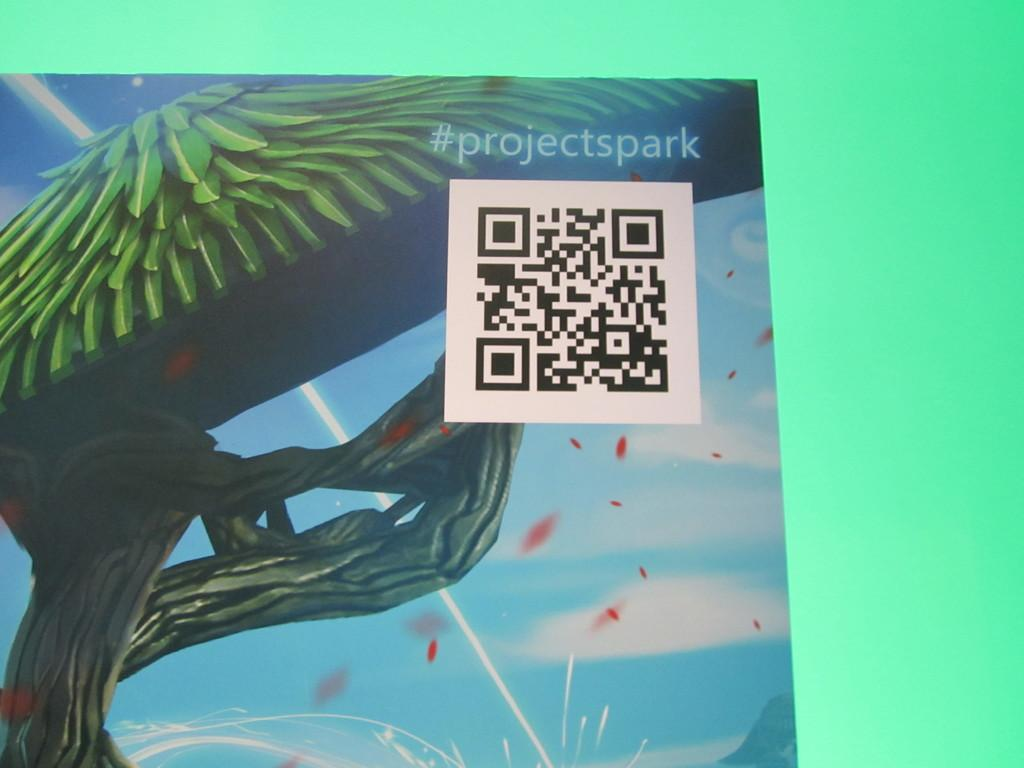What is depicted on the poster in the image? There is a tree on the poster. What additional feature can be found on the poster? There is a QR code on the poster. Is there any other marking on the poster? Yes, there is a watermark on the poster. What color is the background of the poster? The background of the poster is green. What type of war songs are mentioned on the poster? There is no mention of war or songs on the poster; it features a tree, a QR code, a watermark, and a green background. 